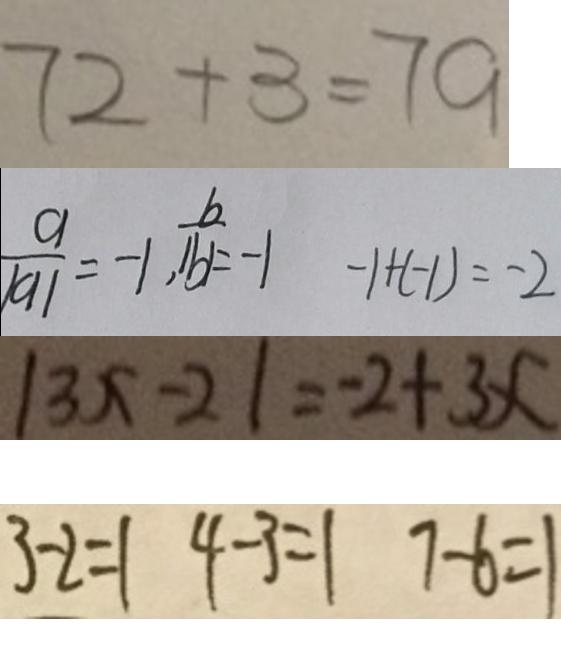<formula> <loc_0><loc_0><loc_500><loc_500>7 2 + 3 = 7 9 
 \frac { a } { \vert a \vert } = - 1 , \frac { b } { \vert b \vert } = - 1 - 1 + ( - 1 ) = - 2 
 \vert 3 x - 2 \vert = - 2 + 3 x 
 3 - 2 = 1 4 - 3 = 1 7 - 6 = 1</formula> 